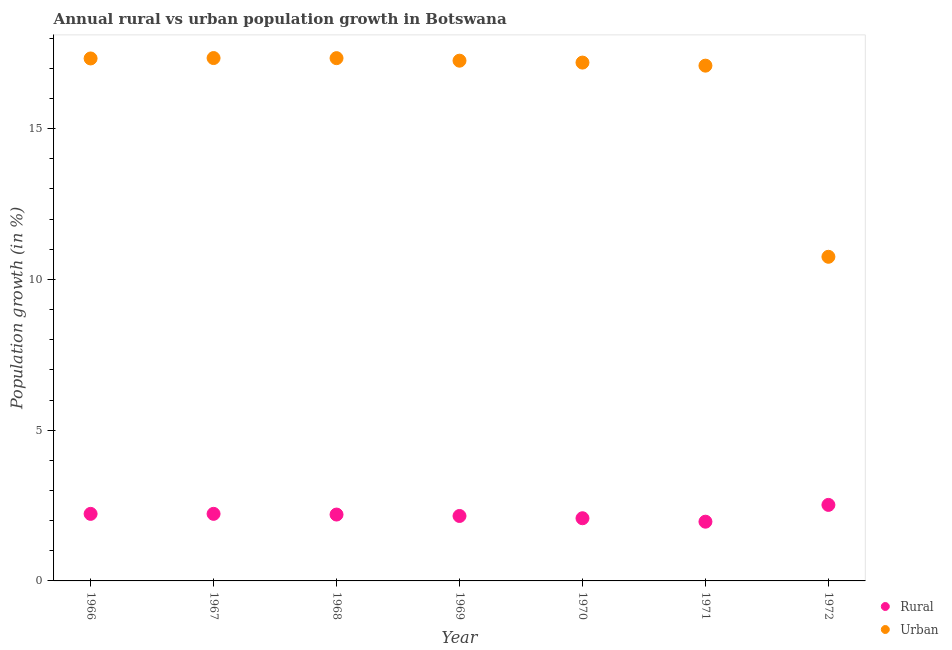Is the number of dotlines equal to the number of legend labels?
Ensure brevity in your answer.  Yes. What is the urban population growth in 1967?
Your answer should be compact. 17.34. Across all years, what is the maximum rural population growth?
Your answer should be very brief. 2.52. Across all years, what is the minimum urban population growth?
Provide a succinct answer. 10.75. In which year was the urban population growth maximum?
Give a very brief answer. 1967. In which year was the urban population growth minimum?
Your response must be concise. 1972. What is the total urban population growth in the graph?
Your response must be concise. 114.29. What is the difference between the rural population growth in 1971 and that in 1972?
Your answer should be compact. -0.56. What is the difference between the urban population growth in 1972 and the rural population growth in 1968?
Your response must be concise. 8.55. What is the average urban population growth per year?
Give a very brief answer. 16.33. In the year 1972, what is the difference between the rural population growth and urban population growth?
Make the answer very short. -8.23. In how many years, is the urban population growth greater than 3 %?
Provide a succinct answer. 7. What is the ratio of the rural population growth in 1969 to that in 1972?
Your answer should be compact. 0.85. What is the difference between the highest and the second highest urban population growth?
Provide a short and direct response. 0. What is the difference between the highest and the lowest urban population growth?
Ensure brevity in your answer.  6.59. In how many years, is the urban population growth greater than the average urban population growth taken over all years?
Offer a terse response. 6. Is the sum of the rural population growth in 1968 and 1972 greater than the maximum urban population growth across all years?
Give a very brief answer. No. Does the urban population growth monotonically increase over the years?
Keep it short and to the point. No. Is the rural population growth strictly greater than the urban population growth over the years?
Offer a very short reply. No. Is the urban population growth strictly less than the rural population growth over the years?
Your answer should be very brief. No. What is the difference between two consecutive major ticks on the Y-axis?
Offer a terse response. 5. Are the values on the major ticks of Y-axis written in scientific E-notation?
Make the answer very short. No. Does the graph contain grids?
Offer a terse response. No. Where does the legend appear in the graph?
Give a very brief answer. Bottom right. What is the title of the graph?
Keep it short and to the point. Annual rural vs urban population growth in Botswana. What is the label or title of the X-axis?
Provide a short and direct response. Year. What is the label or title of the Y-axis?
Your answer should be compact. Population growth (in %). What is the Population growth (in %) of Rural in 1966?
Offer a terse response. 2.22. What is the Population growth (in %) in Urban  in 1966?
Make the answer very short. 17.33. What is the Population growth (in %) of Rural in 1967?
Provide a short and direct response. 2.22. What is the Population growth (in %) in Urban  in 1967?
Offer a very short reply. 17.34. What is the Population growth (in %) of Rural in 1968?
Your response must be concise. 2.2. What is the Population growth (in %) of Urban  in 1968?
Ensure brevity in your answer.  17.34. What is the Population growth (in %) of Rural in 1969?
Your answer should be compact. 2.15. What is the Population growth (in %) of Urban  in 1969?
Provide a succinct answer. 17.25. What is the Population growth (in %) in Rural in 1970?
Provide a succinct answer. 2.08. What is the Population growth (in %) of Urban  in 1970?
Your answer should be very brief. 17.19. What is the Population growth (in %) of Rural in 1971?
Provide a succinct answer. 1.96. What is the Population growth (in %) of Urban  in 1971?
Provide a succinct answer. 17.09. What is the Population growth (in %) of Rural in 1972?
Provide a short and direct response. 2.52. What is the Population growth (in %) of Urban  in 1972?
Keep it short and to the point. 10.75. Across all years, what is the maximum Population growth (in %) of Rural?
Provide a short and direct response. 2.52. Across all years, what is the maximum Population growth (in %) in Urban ?
Provide a short and direct response. 17.34. Across all years, what is the minimum Population growth (in %) in Rural?
Provide a succinct answer. 1.96. Across all years, what is the minimum Population growth (in %) in Urban ?
Give a very brief answer. 10.75. What is the total Population growth (in %) in Rural in the graph?
Your answer should be very brief. 15.37. What is the total Population growth (in %) in Urban  in the graph?
Make the answer very short. 114.29. What is the difference between the Population growth (in %) in Rural in 1966 and that in 1967?
Give a very brief answer. -0. What is the difference between the Population growth (in %) in Urban  in 1966 and that in 1967?
Offer a terse response. -0.01. What is the difference between the Population growth (in %) of Rural in 1966 and that in 1968?
Your answer should be very brief. 0.02. What is the difference between the Population growth (in %) in Urban  in 1966 and that in 1968?
Provide a succinct answer. -0.01. What is the difference between the Population growth (in %) in Rural in 1966 and that in 1969?
Ensure brevity in your answer.  0.07. What is the difference between the Population growth (in %) of Urban  in 1966 and that in 1969?
Keep it short and to the point. 0.07. What is the difference between the Population growth (in %) of Rural in 1966 and that in 1970?
Your answer should be very brief. 0.14. What is the difference between the Population growth (in %) in Urban  in 1966 and that in 1970?
Offer a terse response. 0.14. What is the difference between the Population growth (in %) of Rural in 1966 and that in 1971?
Your answer should be compact. 0.26. What is the difference between the Population growth (in %) of Urban  in 1966 and that in 1971?
Provide a short and direct response. 0.24. What is the difference between the Population growth (in %) of Rural in 1966 and that in 1972?
Your answer should be compact. -0.3. What is the difference between the Population growth (in %) of Urban  in 1966 and that in 1972?
Offer a terse response. 6.58. What is the difference between the Population growth (in %) in Rural in 1967 and that in 1968?
Offer a terse response. 0.02. What is the difference between the Population growth (in %) in Urban  in 1967 and that in 1968?
Give a very brief answer. 0. What is the difference between the Population growth (in %) of Rural in 1967 and that in 1969?
Provide a succinct answer. 0.07. What is the difference between the Population growth (in %) in Urban  in 1967 and that in 1969?
Provide a short and direct response. 0.09. What is the difference between the Population growth (in %) of Rural in 1967 and that in 1970?
Offer a very short reply. 0.15. What is the difference between the Population growth (in %) of Urban  in 1967 and that in 1970?
Make the answer very short. 0.15. What is the difference between the Population growth (in %) of Rural in 1967 and that in 1971?
Your response must be concise. 0.26. What is the difference between the Population growth (in %) in Urban  in 1967 and that in 1971?
Offer a terse response. 0.25. What is the difference between the Population growth (in %) of Rural in 1967 and that in 1972?
Provide a succinct answer. -0.3. What is the difference between the Population growth (in %) of Urban  in 1967 and that in 1972?
Your response must be concise. 6.59. What is the difference between the Population growth (in %) in Rural in 1968 and that in 1969?
Your answer should be compact. 0.05. What is the difference between the Population growth (in %) in Urban  in 1968 and that in 1969?
Give a very brief answer. 0.08. What is the difference between the Population growth (in %) in Rural in 1968 and that in 1970?
Your answer should be compact. 0.12. What is the difference between the Population growth (in %) in Urban  in 1968 and that in 1970?
Keep it short and to the point. 0.15. What is the difference between the Population growth (in %) of Rural in 1968 and that in 1971?
Offer a very short reply. 0.24. What is the difference between the Population growth (in %) in Urban  in 1968 and that in 1971?
Keep it short and to the point. 0.25. What is the difference between the Population growth (in %) of Rural in 1968 and that in 1972?
Your response must be concise. -0.32. What is the difference between the Population growth (in %) in Urban  in 1968 and that in 1972?
Your answer should be compact. 6.59. What is the difference between the Population growth (in %) in Rural in 1969 and that in 1970?
Provide a succinct answer. 0.07. What is the difference between the Population growth (in %) in Urban  in 1969 and that in 1970?
Your answer should be compact. 0.06. What is the difference between the Population growth (in %) of Rural in 1969 and that in 1971?
Your answer should be compact. 0.19. What is the difference between the Population growth (in %) of Urban  in 1969 and that in 1971?
Offer a terse response. 0.16. What is the difference between the Population growth (in %) of Rural in 1969 and that in 1972?
Provide a succinct answer. -0.37. What is the difference between the Population growth (in %) in Urban  in 1969 and that in 1972?
Your answer should be very brief. 6.5. What is the difference between the Population growth (in %) in Rural in 1970 and that in 1971?
Your answer should be very brief. 0.11. What is the difference between the Population growth (in %) in Urban  in 1970 and that in 1971?
Keep it short and to the point. 0.1. What is the difference between the Population growth (in %) of Rural in 1970 and that in 1972?
Your answer should be compact. -0.44. What is the difference between the Population growth (in %) in Urban  in 1970 and that in 1972?
Make the answer very short. 6.44. What is the difference between the Population growth (in %) of Rural in 1971 and that in 1972?
Your answer should be compact. -0.56. What is the difference between the Population growth (in %) of Urban  in 1971 and that in 1972?
Offer a terse response. 6.34. What is the difference between the Population growth (in %) of Rural in 1966 and the Population growth (in %) of Urban  in 1967?
Your response must be concise. -15.12. What is the difference between the Population growth (in %) in Rural in 1966 and the Population growth (in %) in Urban  in 1968?
Offer a terse response. -15.11. What is the difference between the Population growth (in %) in Rural in 1966 and the Population growth (in %) in Urban  in 1969?
Your response must be concise. -15.03. What is the difference between the Population growth (in %) in Rural in 1966 and the Population growth (in %) in Urban  in 1970?
Your answer should be very brief. -14.97. What is the difference between the Population growth (in %) of Rural in 1966 and the Population growth (in %) of Urban  in 1971?
Make the answer very short. -14.87. What is the difference between the Population growth (in %) in Rural in 1966 and the Population growth (in %) in Urban  in 1972?
Your answer should be compact. -8.53. What is the difference between the Population growth (in %) of Rural in 1967 and the Population growth (in %) of Urban  in 1968?
Give a very brief answer. -15.11. What is the difference between the Population growth (in %) of Rural in 1967 and the Population growth (in %) of Urban  in 1969?
Keep it short and to the point. -15.03. What is the difference between the Population growth (in %) of Rural in 1967 and the Population growth (in %) of Urban  in 1970?
Your answer should be compact. -14.97. What is the difference between the Population growth (in %) of Rural in 1967 and the Population growth (in %) of Urban  in 1971?
Make the answer very short. -14.87. What is the difference between the Population growth (in %) of Rural in 1967 and the Population growth (in %) of Urban  in 1972?
Keep it short and to the point. -8.53. What is the difference between the Population growth (in %) of Rural in 1968 and the Population growth (in %) of Urban  in 1969?
Provide a succinct answer. -15.05. What is the difference between the Population growth (in %) in Rural in 1968 and the Population growth (in %) in Urban  in 1970?
Give a very brief answer. -14.99. What is the difference between the Population growth (in %) of Rural in 1968 and the Population growth (in %) of Urban  in 1971?
Give a very brief answer. -14.89. What is the difference between the Population growth (in %) in Rural in 1968 and the Population growth (in %) in Urban  in 1972?
Your answer should be compact. -8.55. What is the difference between the Population growth (in %) in Rural in 1969 and the Population growth (in %) in Urban  in 1970?
Offer a very short reply. -15.04. What is the difference between the Population growth (in %) of Rural in 1969 and the Population growth (in %) of Urban  in 1971?
Offer a very short reply. -14.94. What is the difference between the Population growth (in %) in Rural in 1969 and the Population growth (in %) in Urban  in 1972?
Your answer should be very brief. -8.6. What is the difference between the Population growth (in %) in Rural in 1970 and the Population growth (in %) in Urban  in 1971?
Make the answer very short. -15.01. What is the difference between the Population growth (in %) of Rural in 1970 and the Population growth (in %) of Urban  in 1972?
Make the answer very short. -8.67. What is the difference between the Population growth (in %) in Rural in 1971 and the Population growth (in %) in Urban  in 1972?
Give a very brief answer. -8.79. What is the average Population growth (in %) of Rural per year?
Keep it short and to the point. 2.2. What is the average Population growth (in %) in Urban  per year?
Provide a succinct answer. 16.33. In the year 1966, what is the difference between the Population growth (in %) of Rural and Population growth (in %) of Urban ?
Keep it short and to the point. -15.1. In the year 1967, what is the difference between the Population growth (in %) in Rural and Population growth (in %) in Urban ?
Make the answer very short. -15.12. In the year 1968, what is the difference between the Population growth (in %) of Rural and Population growth (in %) of Urban ?
Keep it short and to the point. -15.14. In the year 1969, what is the difference between the Population growth (in %) in Rural and Population growth (in %) in Urban ?
Offer a very short reply. -15.1. In the year 1970, what is the difference between the Population growth (in %) of Rural and Population growth (in %) of Urban ?
Your response must be concise. -15.11. In the year 1971, what is the difference between the Population growth (in %) of Rural and Population growth (in %) of Urban ?
Ensure brevity in your answer.  -15.12. In the year 1972, what is the difference between the Population growth (in %) of Rural and Population growth (in %) of Urban ?
Your response must be concise. -8.23. What is the ratio of the Population growth (in %) of Rural in 1966 to that in 1967?
Your response must be concise. 1. What is the ratio of the Population growth (in %) of Rural in 1966 to that in 1968?
Offer a terse response. 1.01. What is the ratio of the Population growth (in %) in Urban  in 1966 to that in 1968?
Offer a very short reply. 1. What is the ratio of the Population growth (in %) in Rural in 1966 to that in 1969?
Give a very brief answer. 1.03. What is the ratio of the Population growth (in %) in Urban  in 1966 to that in 1969?
Offer a very short reply. 1. What is the ratio of the Population growth (in %) in Rural in 1966 to that in 1970?
Offer a terse response. 1.07. What is the ratio of the Population growth (in %) in Urban  in 1966 to that in 1970?
Provide a succinct answer. 1.01. What is the ratio of the Population growth (in %) of Rural in 1966 to that in 1971?
Offer a terse response. 1.13. What is the ratio of the Population growth (in %) in Rural in 1966 to that in 1972?
Your response must be concise. 0.88. What is the ratio of the Population growth (in %) of Urban  in 1966 to that in 1972?
Give a very brief answer. 1.61. What is the ratio of the Population growth (in %) of Rural in 1967 to that in 1968?
Your answer should be compact. 1.01. What is the ratio of the Population growth (in %) in Urban  in 1967 to that in 1968?
Your response must be concise. 1. What is the ratio of the Population growth (in %) in Rural in 1967 to that in 1969?
Ensure brevity in your answer.  1.03. What is the ratio of the Population growth (in %) of Rural in 1967 to that in 1970?
Provide a succinct answer. 1.07. What is the ratio of the Population growth (in %) in Urban  in 1967 to that in 1970?
Ensure brevity in your answer.  1.01. What is the ratio of the Population growth (in %) of Rural in 1967 to that in 1971?
Keep it short and to the point. 1.13. What is the ratio of the Population growth (in %) in Urban  in 1967 to that in 1971?
Your answer should be very brief. 1.01. What is the ratio of the Population growth (in %) of Rural in 1967 to that in 1972?
Give a very brief answer. 0.88. What is the ratio of the Population growth (in %) of Urban  in 1967 to that in 1972?
Offer a terse response. 1.61. What is the ratio of the Population growth (in %) in Rural in 1968 to that in 1969?
Your answer should be very brief. 1.02. What is the ratio of the Population growth (in %) in Rural in 1968 to that in 1970?
Provide a succinct answer. 1.06. What is the ratio of the Population growth (in %) in Urban  in 1968 to that in 1970?
Your answer should be compact. 1.01. What is the ratio of the Population growth (in %) of Rural in 1968 to that in 1971?
Your answer should be compact. 1.12. What is the ratio of the Population growth (in %) in Urban  in 1968 to that in 1971?
Make the answer very short. 1.01. What is the ratio of the Population growth (in %) of Rural in 1968 to that in 1972?
Provide a short and direct response. 0.87. What is the ratio of the Population growth (in %) in Urban  in 1968 to that in 1972?
Offer a terse response. 1.61. What is the ratio of the Population growth (in %) of Rural in 1969 to that in 1970?
Make the answer very short. 1.04. What is the ratio of the Population growth (in %) of Rural in 1969 to that in 1971?
Offer a very short reply. 1.1. What is the ratio of the Population growth (in %) of Urban  in 1969 to that in 1971?
Offer a terse response. 1.01. What is the ratio of the Population growth (in %) in Rural in 1969 to that in 1972?
Keep it short and to the point. 0.85. What is the ratio of the Population growth (in %) in Urban  in 1969 to that in 1972?
Give a very brief answer. 1.6. What is the ratio of the Population growth (in %) in Rural in 1970 to that in 1971?
Offer a very short reply. 1.06. What is the ratio of the Population growth (in %) in Urban  in 1970 to that in 1971?
Your answer should be very brief. 1.01. What is the ratio of the Population growth (in %) of Rural in 1970 to that in 1972?
Your answer should be compact. 0.82. What is the ratio of the Population growth (in %) of Urban  in 1970 to that in 1972?
Offer a very short reply. 1.6. What is the ratio of the Population growth (in %) in Rural in 1971 to that in 1972?
Make the answer very short. 0.78. What is the ratio of the Population growth (in %) of Urban  in 1971 to that in 1972?
Your answer should be very brief. 1.59. What is the difference between the highest and the second highest Population growth (in %) in Rural?
Make the answer very short. 0.3. What is the difference between the highest and the second highest Population growth (in %) in Urban ?
Your answer should be compact. 0. What is the difference between the highest and the lowest Population growth (in %) in Rural?
Offer a very short reply. 0.56. What is the difference between the highest and the lowest Population growth (in %) in Urban ?
Make the answer very short. 6.59. 